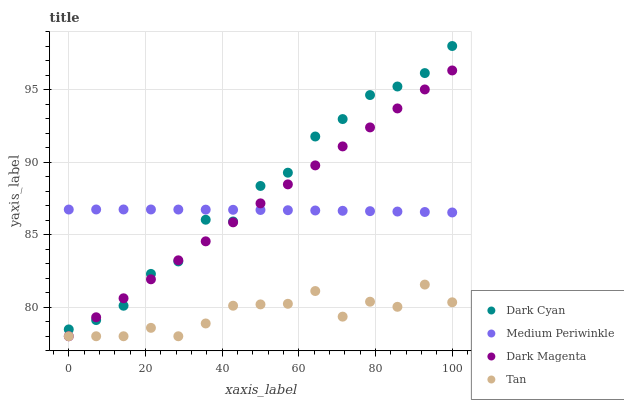Does Tan have the minimum area under the curve?
Answer yes or no. Yes. Does Dark Cyan have the maximum area under the curve?
Answer yes or no. Yes. Does Medium Periwinkle have the minimum area under the curve?
Answer yes or no. No. Does Medium Periwinkle have the maximum area under the curve?
Answer yes or no. No. Is Dark Magenta the smoothest?
Answer yes or no. Yes. Is Dark Cyan the roughest?
Answer yes or no. Yes. Is Tan the smoothest?
Answer yes or no. No. Is Tan the roughest?
Answer yes or no. No. Does Tan have the lowest value?
Answer yes or no. Yes. Does Medium Periwinkle have the lowest value?
Answer yes or no. No. Does Dark Cyan have the highest value?
Answer yes or no. Yes. Does Medium Periwinkle have the highest value?
Answer yes or no. No. Is Tan less than Dark Cyan?
Answer yes or no. Yes. Is Medium Periwinkle greater than Tan?
Answer yes or no. Yes. Does Medium Periwinkle intersect Dark Magenta?
Answer yes or no. Yes. Is Medium Periwinkle less than Dark Magenta?
Answer yes or no. No. Is Medium Periwinkle greater than Dark Magenta?
Answer yes or no. No. Does Tan intersect Dark Cyan?
Answer yes or no. No. 